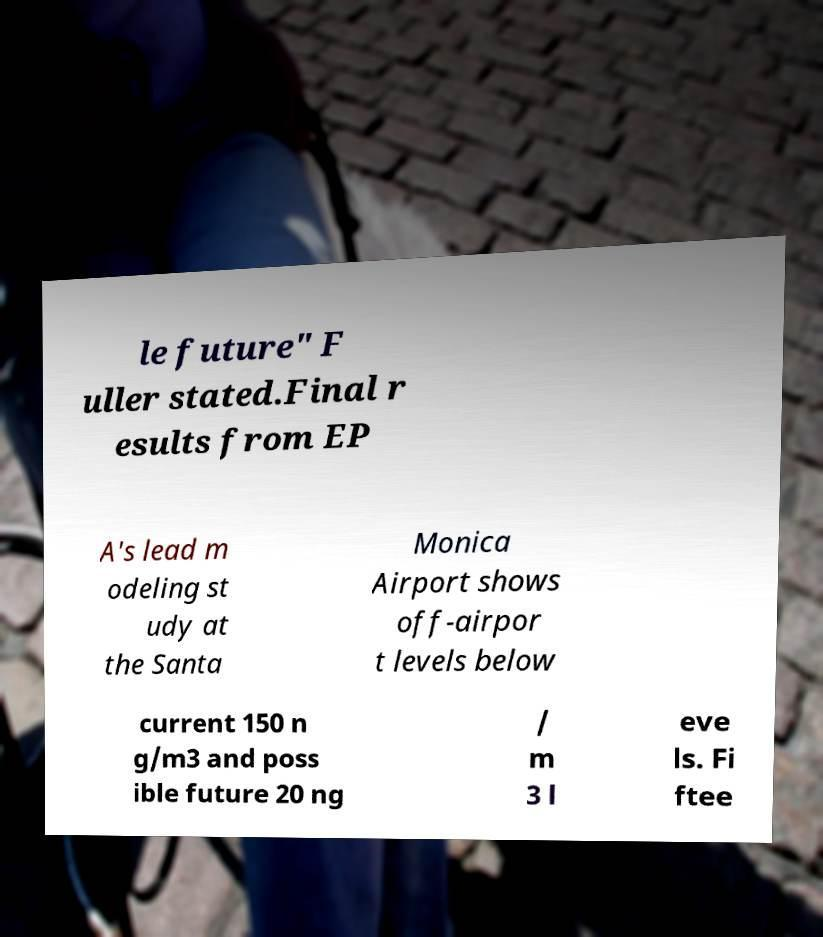There's text embedded in this image that I need extracted. Can you transcribe it verbatim? le future" F uller stated.Final r esults from EP A's lead m odeling st udy at the Santa Monica Airport shows off-airpor t levels below current 150 n g/m3 and poss ible future 20 ng / m 3 l eve ls. Fi ftee 